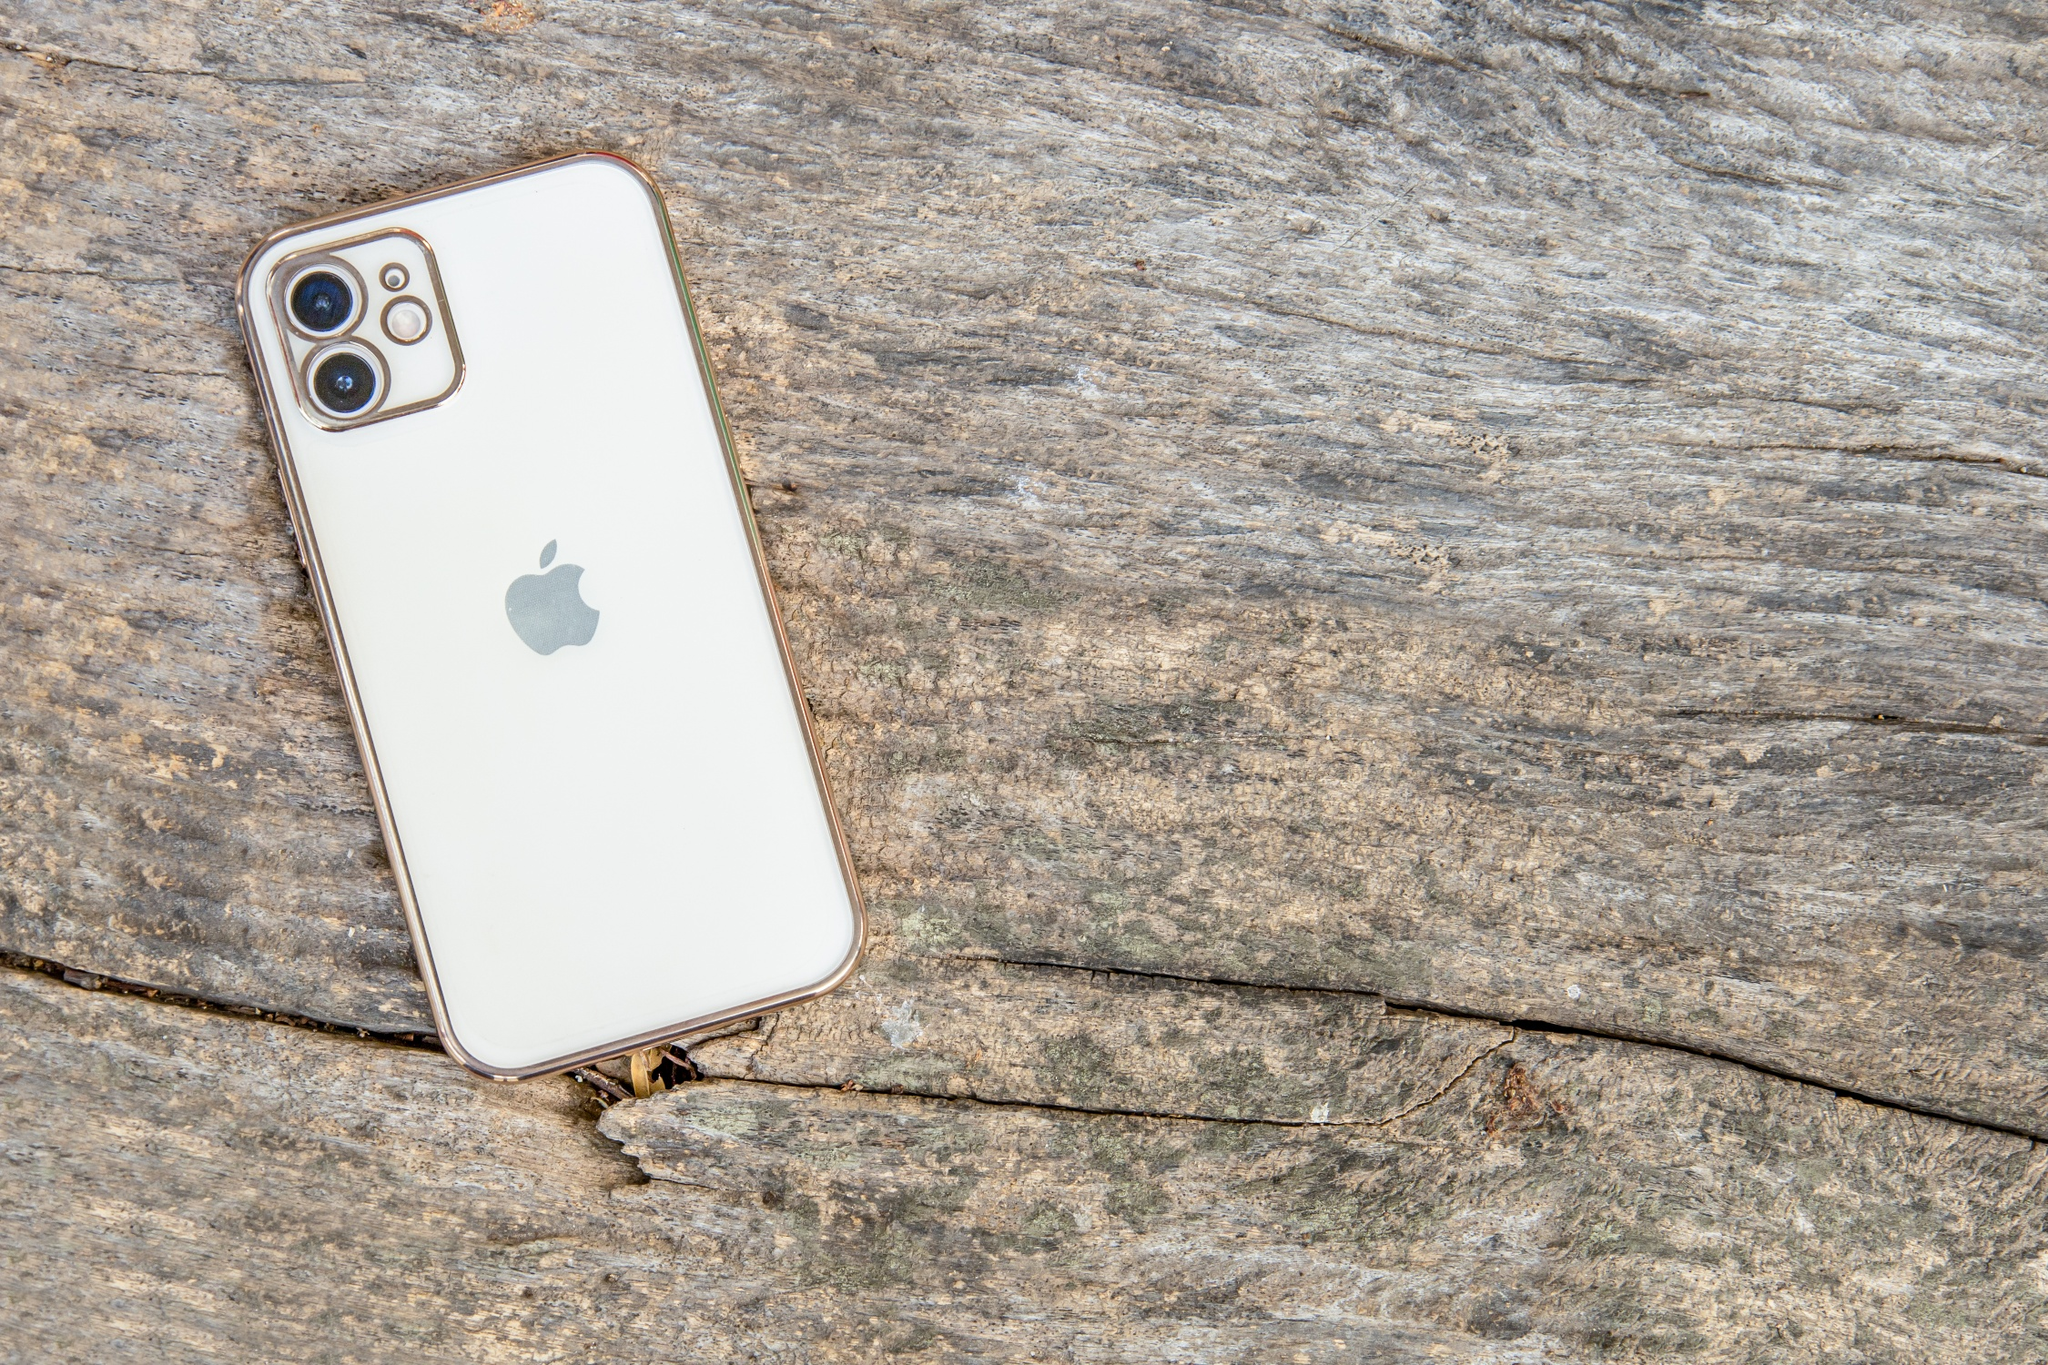Describe the contrast between the iPhone and the wooden surface. The image presents a striking contrast between the sleek, modern design of the iPhone and the rough, natural texture of the wooden surface. The iPhone, with its pristine white back and shiny silver border, epitomizes contemporary technology and sophistication. Meanwhile, the wooden surface, with its visible cracks and weathered appearance, tells a story of natural wear and passage of time. This juxtaposition highlights the clash between modern innovation and the enduring, untamed beauty of nature. 